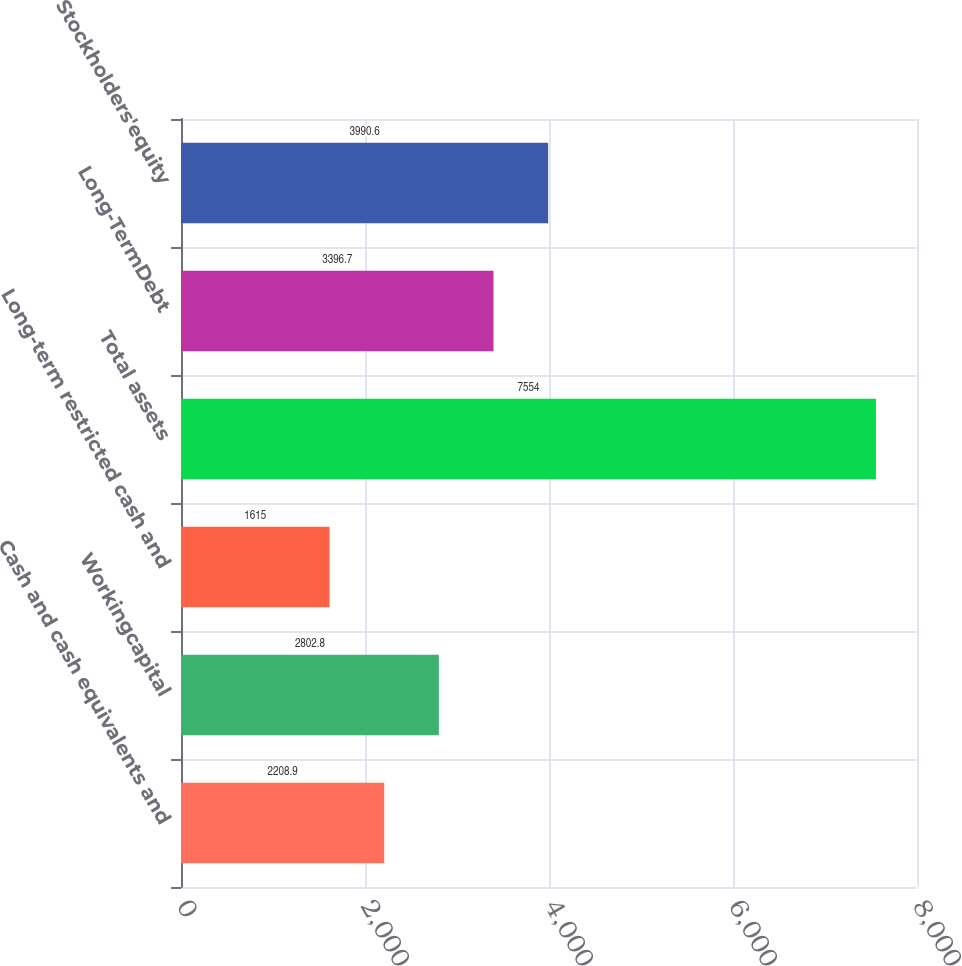<chart> <loc_0><loc_0><loc_500><loc_500><bar_chart><fcel>Cash and cash equivalents and<fcel>Workingcapital<fcel>Long-term restricted cash and<fcel>Total assets<fcel>Long-TermDebt<fcel>Stockholders'equity<nl><fcel>2208.9<fcel>2802.8<fcel>1615<fcel>7554<fcel>3396.7<fcel>3990.6<nl></chart> 